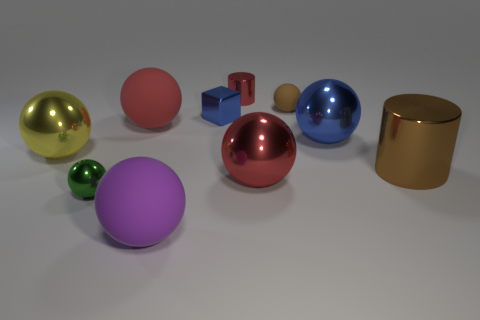What number of other blue blocks have the same size as the cube? 0 